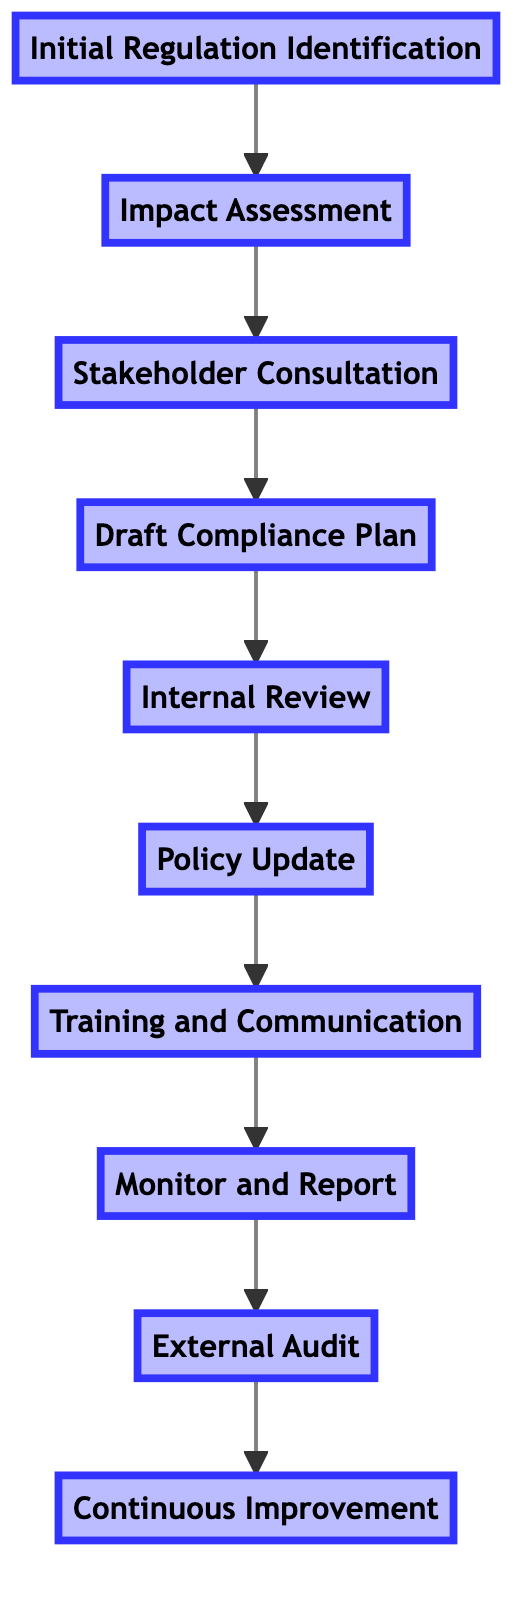What is the first step in the compliance review process? The first step is "Initial Regulation Identification," which is positioned at the bottom of the flow chart.
Answer: Initial Regulation Identification How many nodes are present in the compliance review process? The flow chart contains ten distinct nodes that represent each step of the compliance review process.
Answer: 10 Which step comes after "Internal Review"? According to the flow, the step that follows "Internal Review" is "Policy Update."
Answer: Policy Update What is the last step of the compliance review process? The final step depicted in the diagram is "Continuous Improvement," which is placed at the top of the flow chart.
Answer: Continuous Improvement What is the primary action taken during "Stakeholder Consultation"? The main action in this step is to engage legal, compliance, and business units for insights and feedback.
Answer: Engage legal, compliance, and business units How many steps are involved before "Monitor and Report"? There are six steps that take place before reaching "Monitor and Report." They are: Initial Regulation Identification, Impact Assessment, Stakeholder Consultation, Draft Compliance Plan, Internal Review, and Policy Update.
Answer: 6 Which step immediately precedes "External Audit"? The step that comes directly before "External Audit" is "Monitor and Report."
Answer: Monitor and Report What type of feedback is implemented in the "Continuous Improvement" step? This step focuses on feedback obtained from the "External Audit" conducted prior.
Answer: Feedback from External Audit Which two steps directly relate to training? The steps connected to training are "Training and Communication" and "Internal Review," as the latter ensures the plan is approved before any training can occur.
Answer: Training and Communication, Internal Review 